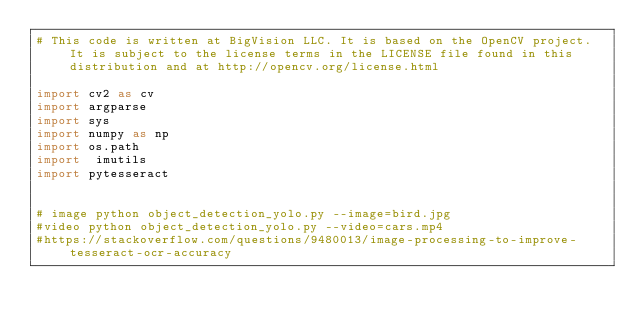Convert code to text. <code><loc_0><loc_0><loc_500><loc_500><_Python_># This code is written at BigVision LLC. It is based on the OpenCV project. It is subject to the license terms in the LICENSE file found in this distribution and at http://opencv.org/license.html

import cv2 as cv
import argparse
import sys
import numpy as np
import os.path
import  imutils
import pytesseract


# image python object_detection_yolo.py --image=bird.jpg
#video python object_detection_yolo.py --video=cars.mp4
#https://stackoverflow.com/questions/9480013/image-processing-to-improve-tesseract-ocr-accuracy
</code> 